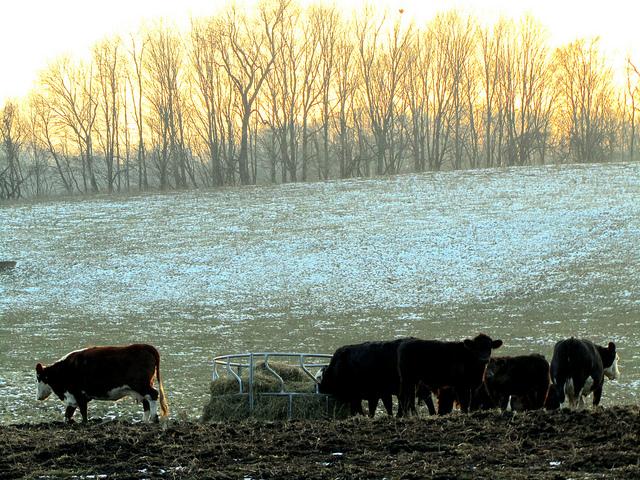What are the cows eating?
Give a very brief answer. Hay. Are these dairy cows?
Answer briefly. Yes. What kind of day is it?
Answer briefly. Cold. 